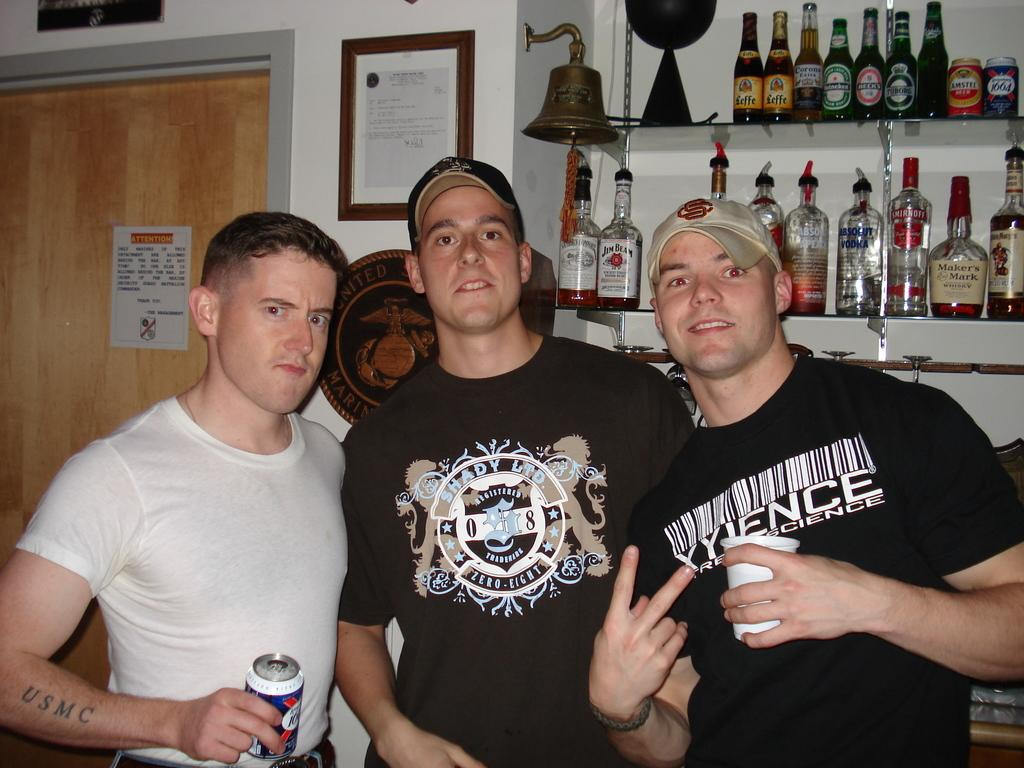What can be seen in the center of the image? There are men standing in the center of the image. What objects are visible in the background area? There are bottles, a door, a frame, a poster, and a bell in the background area. What type of farm animals can be seen in the image? There are no farm animals present in the image. What hobbies do the men in the image engage in? The provided facts do not give any information about the men's hobbies. --- 